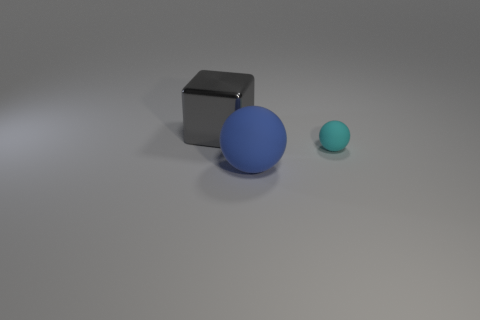What could be the possible use of these objects in a real-world setting? The small gray metal cube could be a paperweight or a minimalist decorative item. The blue and cyan spheres could be children's toys or part of a color-coded organizational system, like stress balls or props for a game. 